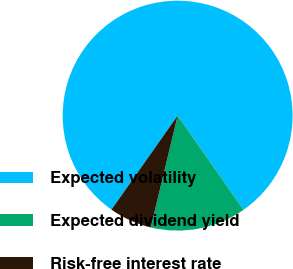Convert chart to OTSL. <chart><loc_0><loc_0><loc_500><loc_500><pie_chart><fcel>Expected volatility<fcel>Expected dividend yield<fcel>Risk-free interest rate<nl><fcel>80.52%<fcel>13.47%<fcel>6.01%<nl></chart> 